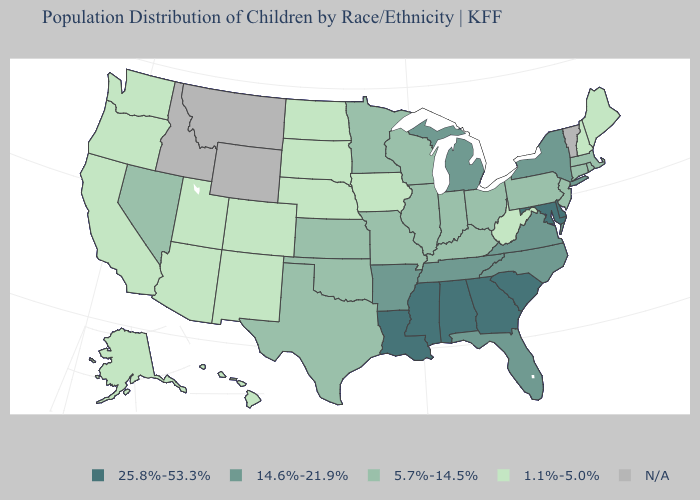Name the states that have a value in the range N/A?
Give a very brief answer. Idaho, Montana, Vermont, Wyoming. Which states have the lowest value in the USA?
Give a very brief answer. Alaska, Arizona, California, Colorado, Hawaii, Iowa, Maine, Nebraska, New Hampshire, New Mexico, North Dakota, Oregon, South Dakota, Utah, Washington, West Virginia. What is the lowest value in the USA?
Answer briefly. 1.1%-5.0%. What is the lowest value in the MidWest?
Short answer required. 1.1%-5.0%. Does the map have missing data?
Quick response, please. Yes. Among the states that border Iowa , which have the lowest value?
Give a very brief answer. Nebraska, South Dakota. What is the highest value in states that border Massachusetts?
Give a very brief answer. 14.6%-21.9%. What is the value of West Virginia?
Concise answer only. 1.1%-5.0%. Does Arkansas have the lowest value in the USA?
Keep it brief. No. What is the lowest value in the MidWest?
Be succinct. 1.1%-5.0%. Name the states that have a value in the range 5.7%-14.5%?
Give a very brief answer. Connecticut, Illinois, Indiana, Kansas, Kentucky, Massachusetts, Minnesota, Missouri, Nevada, New Jersey, Ohio, Oklahoma, Pennsylvania, Rhode Island, Texas, Wisconsin. Does the first symbol in the legend represent the smallest category?
Quick response, please. No. How many symbols are there in the legend?
Keep it brief. 5. What is the lowest value in the South?
Be succinct. 1.1%-5.0%. 